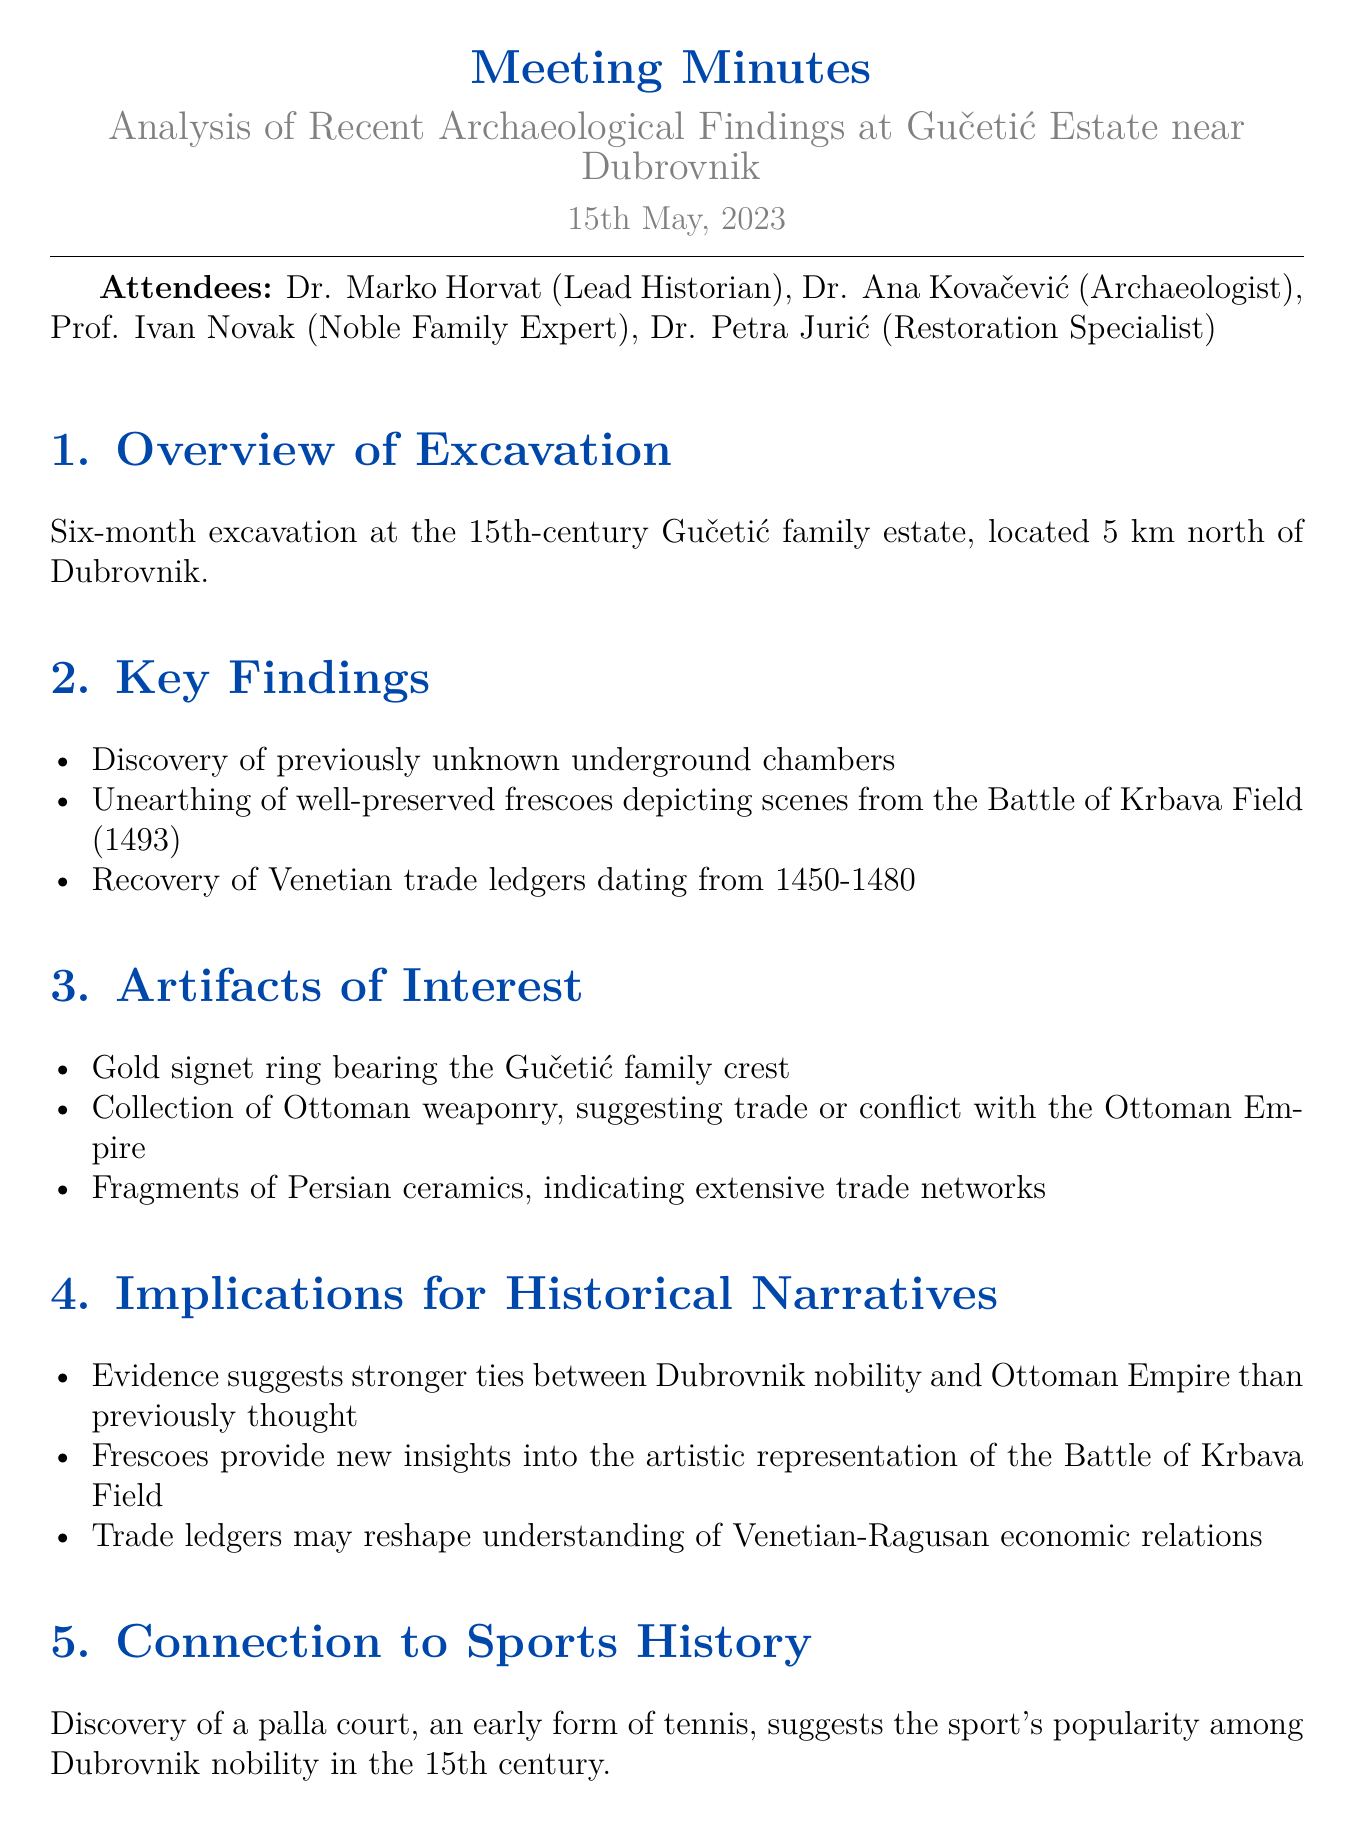What is the date of the meeting? The date of the meeting is explicitly mentioned in the document.
Answer: 15th May, 2023 Who is the lead historian? The lead historian's name is stated in the "Attendees" section of the document.
Answer: Dr. Marko Horvat What was discovered during the excavation? The document lists key findings from the excavation, including several significant items.
Answer: Underground chambers How long was the excavation? The duration of the excavation is specified at the beginning of the document.
Answer: Six months What does the discovery of the palla court suggest? The connection to sports history implies the popularity of an early sport among nobility based on the findings.
Answer: Popularity of the sport How do the Venetian trade ledgers affect our understanding? The implications section indicates how the trade ledgers may influence historical perspectives.
Answer: Reshape understanding What was the purpose of the next steps? The next steps outlined in the document provide a direction after the findings, indicating their significance.
Answer: Further analysis What artwork was found related to the Battle of Krbava Field? The document specifies that well-preserved frescoes were discovered depicting a historical event.
Answer: Frescoes depicting scenes from the Battle of Krbava Field Which family crest was found as an artifact? An important artifact related to a specific family is mentioned in the "Artifacts of Interest" section.
Answer: Gučetić family crest 